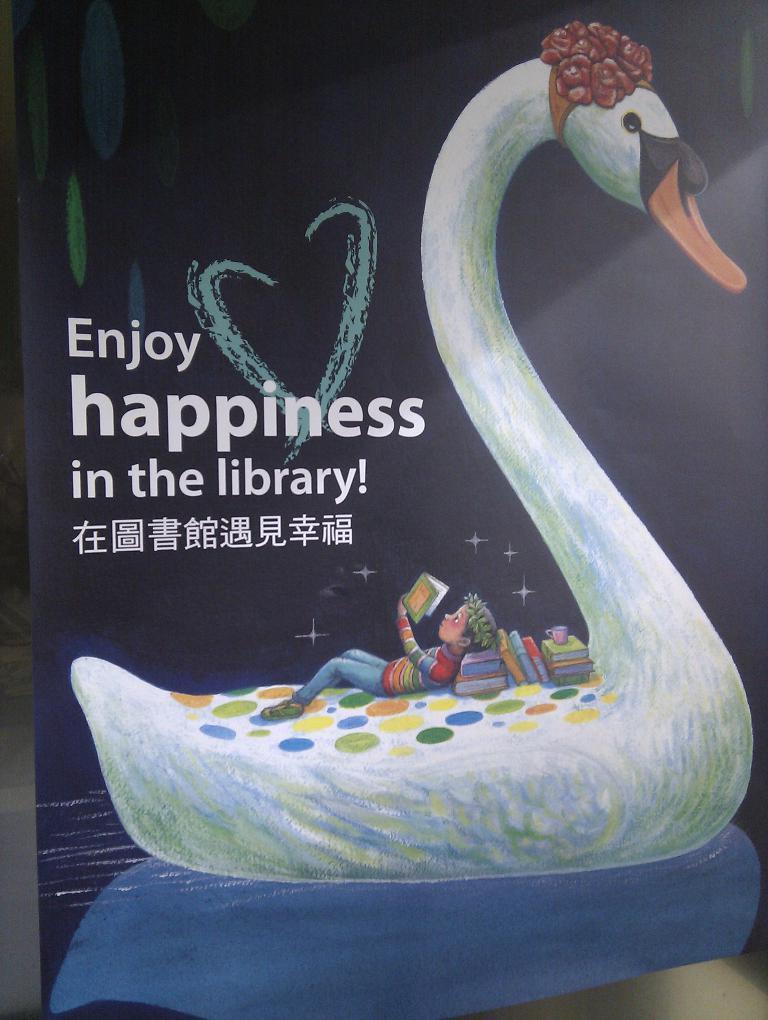In one or two sentences, can you explain what this image depicts? In this picture I can see there is a boy lying on the swan and he is reading books and there are some other books here and this is a cover page of a book. 